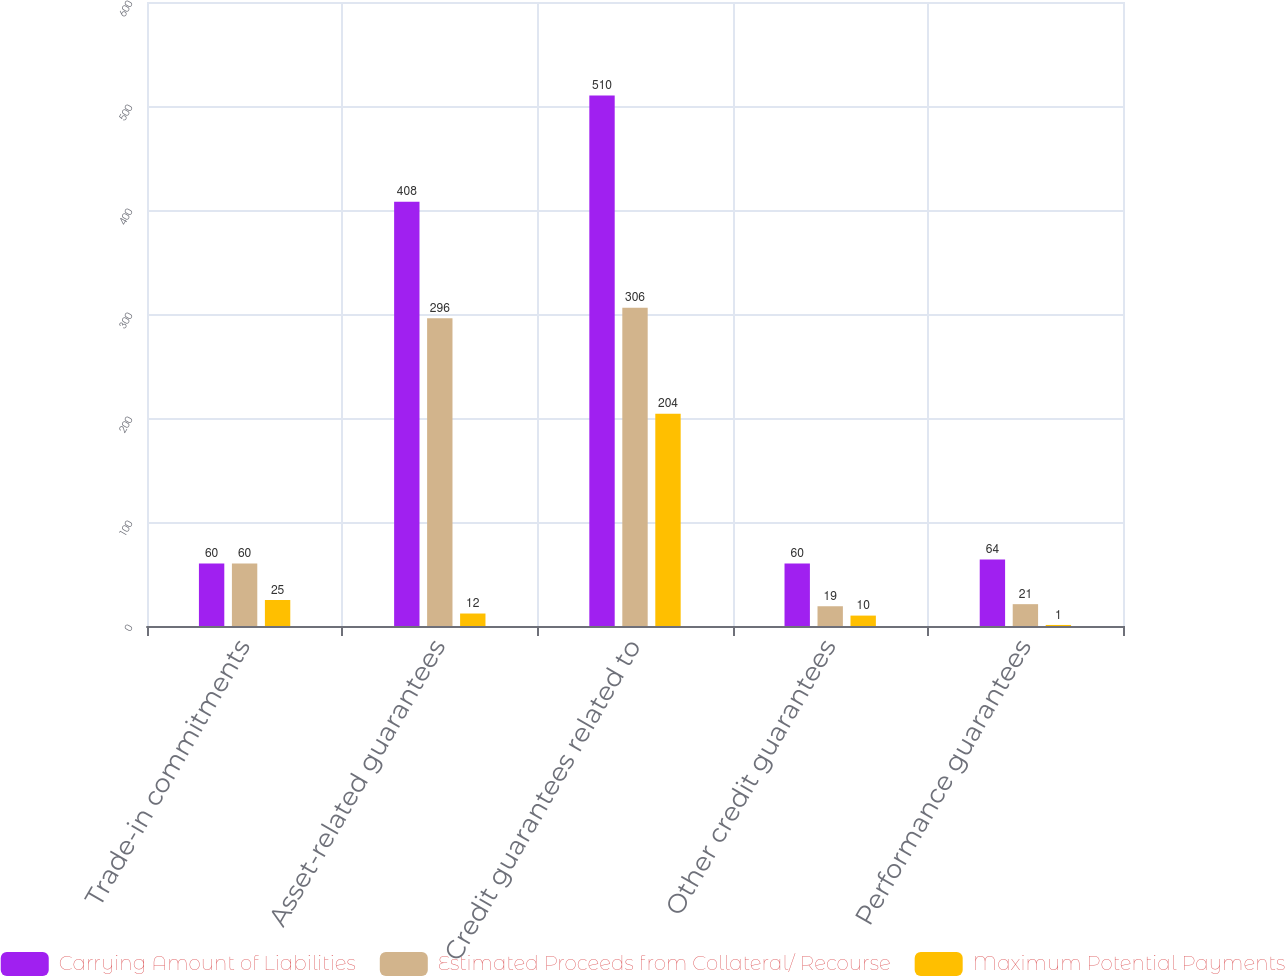Convert chart to OTSL. <chart><loc_0><loc_0><loc_500><loc_500><stacked_bar_chart><ecel><fcel>Trade-in commitments<fcel>Asset-related guarantees<fcel>Credit guarantees related to<fcel>Other credit guarantees<fcel>Performance guarantees<nl><fcel>Carrying Amount of Liabilities<fcel>60<fcel>408<fcel>510<fcel>60<fcel>64<nl><fcel>Estimated Proceeds from Collateral/ Recourse<fcel>60<fcel>296<fcel>306<fcel>19<fcel>21<nl><fcel>Maximum Potential Payments<fcel>25<fcel>12<fcel>204<fcel>10<fcel>1<nl></chart> 